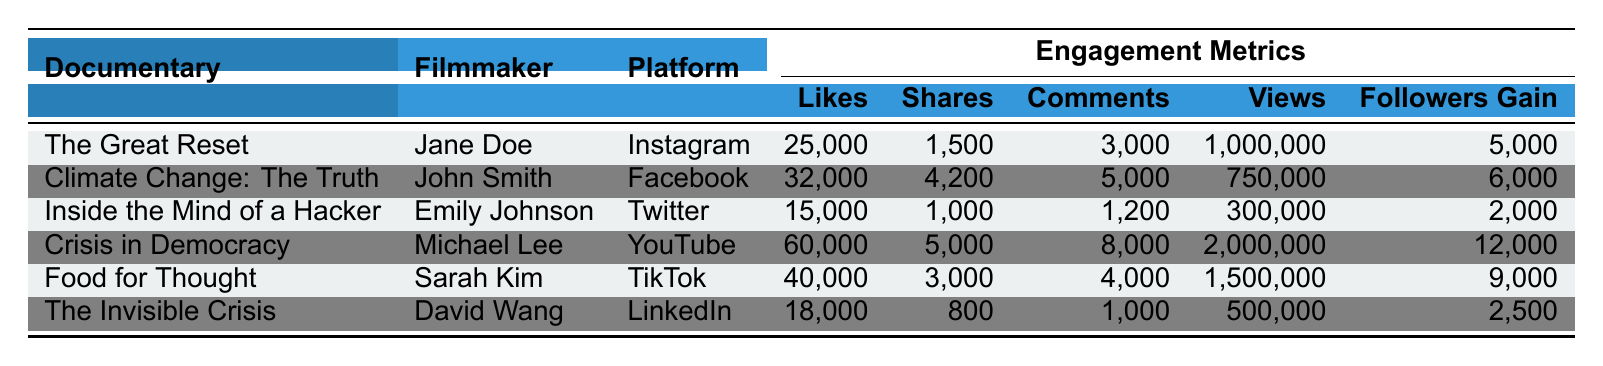What documentary had the highest number of likes? The documentary "Crisis in Democracy" has the highest number of likes at 60,000.
Answer: Crisis in Democracy Which platform generated the least followers gain? "Inside the Mind of a Hacker" on Twitter generated the least followers gain, which is 2,000.
Answer: Twitter What is the total number of comments for all the documentaries? To find the total comments, sum the comments for each documentary: 3,000 + 5,000 + 1,200 + 8,000 + 4,000 + 1,000 = 22,200.
Answer: 22,200 Is the number of shares for "Food for Thought" greater than that for "The Invisible Crisis"? "Food for Thought" has 3,000 shares, while "The Invisible Crisis" has 800 shares, so yes, it is greater.
Answer: Yes What percentage of the total views does "The Great Reset" represent? Total views are calculated as 1,000,000 + 750,000 + 300,000 + 2,000,000 + 1,500,000 + 500,000 = 6,050,000. "The Great Reset" has 1,000,000 views, so the percentage is (1,000,000 / 6,050,000) * 100 ≈ 16.53%.
Answer: 16.53% What is the average likes per documentary? The total number of likes is 25,000 + 32,000 + 15,000 + 60,000 + 40,000 + 18,000 = 190,000. Dividing by the number of documentaries (6) gives an average of 190,000 / 6 ≈ 31,666.67.
Answer: 31,666.67 Which filmmaker had the highest followers gain? Michael Lee, filmmaker of "Crisis in Democracy," had the highest followers gain at 12,000.
Answer: Michael Lee How many more views did "Crisis in Democracy" receive compared to "Climate Change: The Truth"? "Crisis in Democracy" had 2,000,000 views and "Climate Change: The Truth" had 750,000 views. The difference is 2,000,000 - 750,000 = 1,250,000.
Answer: 1,250,000 What platform had the second highest number of shares? The platform with the second highest shares is TikTok with 3,000 shares for "Food for Thought", following Facebook with 4,200.
Answer: TikTok Are there more likes for "Inside the Mind of a Hacker" than the total comments across all documentaries? "Inside the Mind of a Hacker" has 15,000 likes while the total comments are 22,200, so no, there are not more likes.
Answer: No 